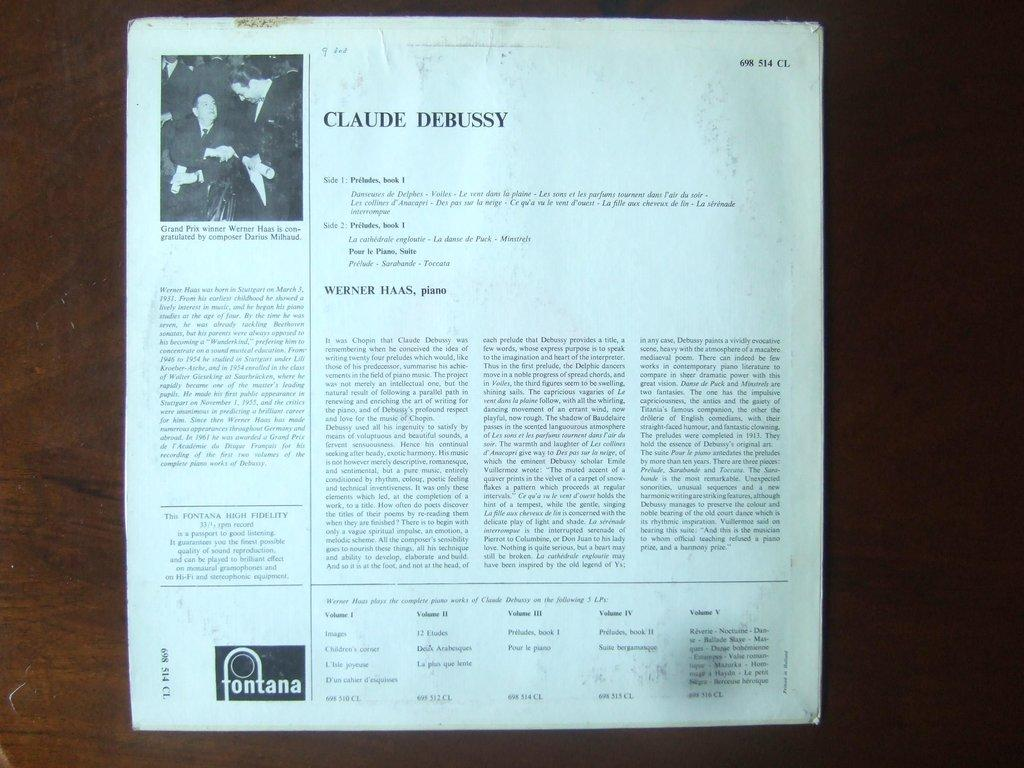<image>
Share a concise interpretation of the image provided. An article is written all about Claude Debussy. 